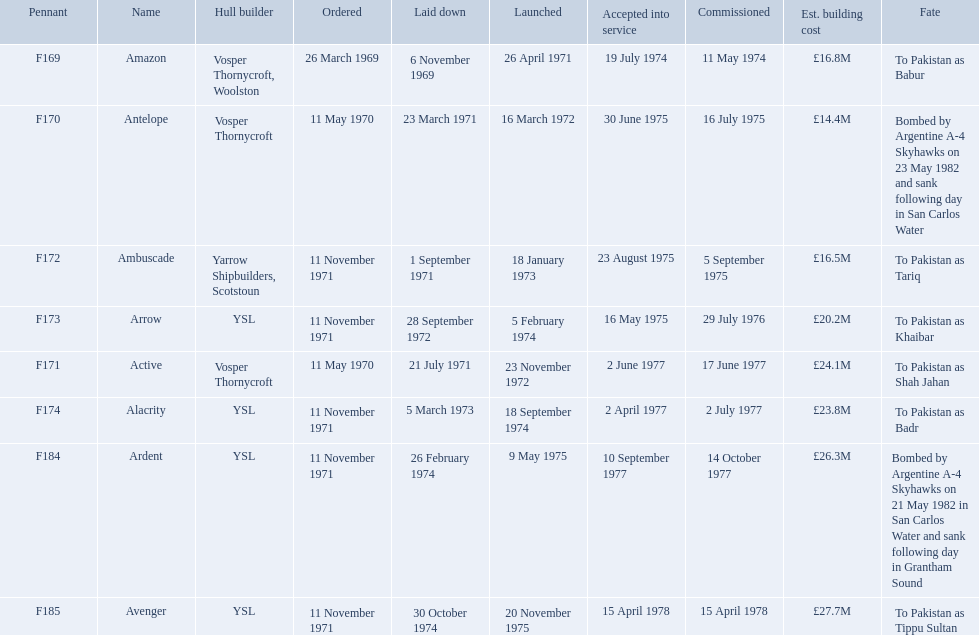Which type 21 frigate ships were to be built by ysl in the 1970s? Arrow, Alacrity, Ardent, Avenger. Of these ships, which one had the highest estimated building cost? Avenger. What were the estimated building costs of the frigates? £16.8M, £14.4M, £16.5M, £20.2M, £24.1M, £23.8M, £26.3M, £27.7M. Parse the full table in json format. {'header': ['Pennant', 'Name', 'Hull builder', 'Ordered', 'Laid down', 'Launched', 'Accepted into service', 'Commissioned', 'Est. building cost', 'Fate'], 'rows': [['F169', 'Amazon', 'Vosper Thornycroft, Woolston', '26 March 1969', '6 November 1969', '26 April 1971', '19 July 1974', '11 May 1974', '£16.8M', 'To Pakistan as Babur'], ['F170', 'Antelope', 'Vosper Thornycroft', '11 May 1970', '23 March 1971', '16 March 1972', '30 June 1975', '16 July 1975', '£14.4M', 'Bombed by Argentine A-4 Skyhawks on 23 May 1982 and sank following day in San Carlos Water'], ['F172', 'Ambuscade', 'Yarrow Shipbuilders, Scotstoun', '11 November 1971', '1 September 1971', '18 January 1973', '23 August 1975', '5 September 1975', '£16.5M', 'To Pakistan as Tariq'], ['F173', 'Arrow', 'YSL', '11 November 1971', '28 September 1972', '5 February 1974', '16 May 1975', '29 July 1976', '£20.2M', 'To Pakistan as Khaibar'], ['F171', 'Active', 'Vosper Thornycroft', '11 May 1970', '21 July 1971', '23 November 1972', '2 June 1977', '17 June 1977', '£24.1M', 'To Pakistan as Shah Jahan'], ['F174', 'Alacrity', 'YSL', '11 November 1971', '5 March 1973', '18 September 1974', '2 April 1977', '2 July 1977', '£23.8M', 'To Pakistan as Badr'], ['F184', 'Ardent', 'YSL', '11 November 1971', '26 February 1974', '9 May 1975', '10 September 1977', '14 October 1977', '£26.3M', 'Bombed by Argentine A-4 Skyhawks on 21 May 1982 in San Carlos Water and sank following day in Grantham Sound'], ['F185', 'Avenger', 'YSL', '11 November 1971', '30 October 1974', '20 November 1975', '15 April 1978', '15 April 1978', '£27.7M', 'To Pakistan as Tippu Sultan']]} Which of these is the largest? £27.7M. What ship name does that correspond to? Avenger. What were the projected construction expenses of the frigates? £16.8M, £14.4M, £16.5M, £20.2M, £24.1M, £23.8M, £26.3M, £27.7M. Which one is the biggest? £27.7M. What is the name of that ship? Avenger. 